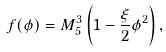<formula> <loc_0><loc_0><loc_500><loc_500>f ( \phi ) = M _ { 5 } ^ { 3 } \left ( 1 - \frac { \xi } { 2 } \phi ^ { 2 } \right ) ,</formula> 